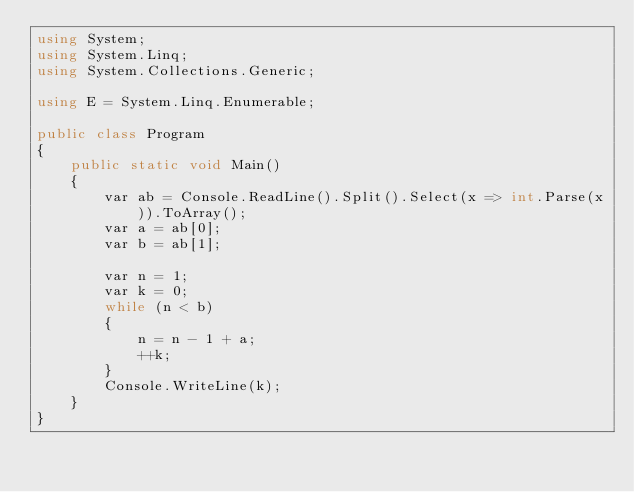<code> <loc_0><loc_0><loc_500><loc_500><_C#_>using System;
using System.Linq;
using System.Collections.Generic;

using E = System.Linq.Enumerable;

public class Program
{
    public static void Main()
    {
        var ab = Console.ReadLine().Split().Select(x => int.Parse(x)).ToArray();
        var a = ab[0];
        var b = ab[1];

        var n = 1;
        var k = 0;
        while (n < b)
        {
            n = n - 1 + a;
            ++k;
        }
        Console.WriteLine(k);
    }
}
</code> 